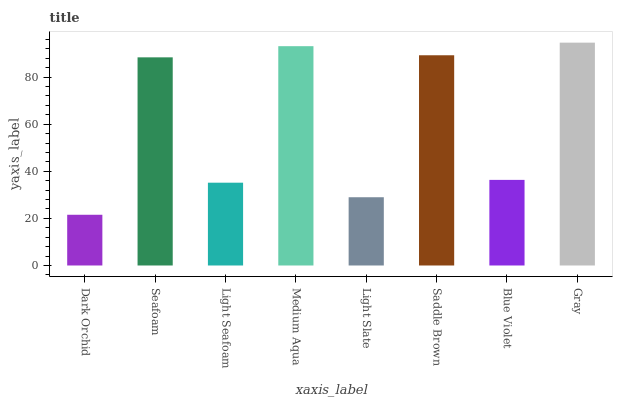Is Seafoam the minimum?
Answer yes or no. No. Is Seafoam the maximum?
Answer yes or no. No. Is Seafoam greater than Dark Orchid?
Answer yes or no. Yes. Is Dark Orchid less than Seafoam?
Answer yes or no. Yes. Is Dark Orchid greater than Seafoam?
Answer yes or no. No. Is Seafoam less than Dark Orchid?
Answer yes or no. No. Is Seafoam the high median?
Answer yes or no. Yes. Is Blue Violet the low median?
Answer yes or no. Yes. Is Light Slate the high median?
Answer yes or no. No. Is Dark Orchid the low median?
Answer yes or no. No. 